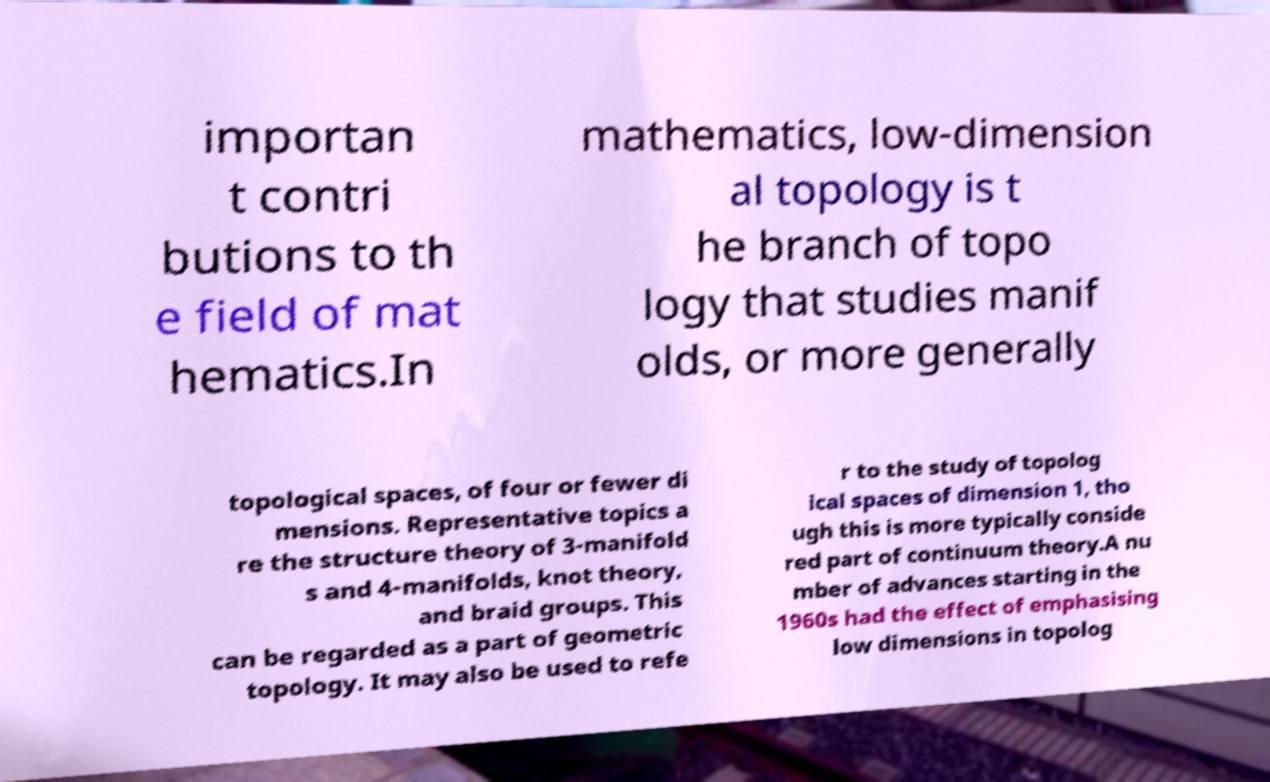What messages or text are displayed in this image? I need them in a readable, typed format. importan t contri butions to th e field of mat hematics.In mathematics, low-dimension al topology is t he branch of topo logy that studies manif olds, or more generally topological spaces, of four or fewer di mensions. Representative topics a re the structure theory of 3-manifold s and 4-manifolds, knot theory, and braid groups. This can be regarded as a part of geometric topology. It may also be used to refe r to the study of topolog ical spaces of dimension 1, tho ugh this is more typically conside red part of continuum theory.A nu mber of advances starting in the 1960s had the effect of emphasising low dimensions in topolog 